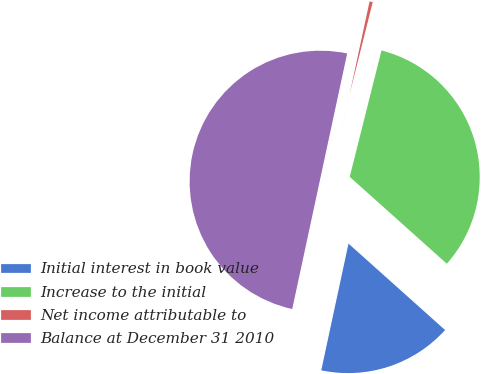Convert chart to OTSL. <chart><loc_0><loc_0><loc_500><loc_500><pie_chart><fcel>Initial interest in book value<fcel>Increase to the initial<fcel>Net income attributable to<fcel>Balance at December 31 2010<nl><fcel>16.75%<fcel>32.7%<fcel>0.55%<fcel>50.0%<nl></chart> 